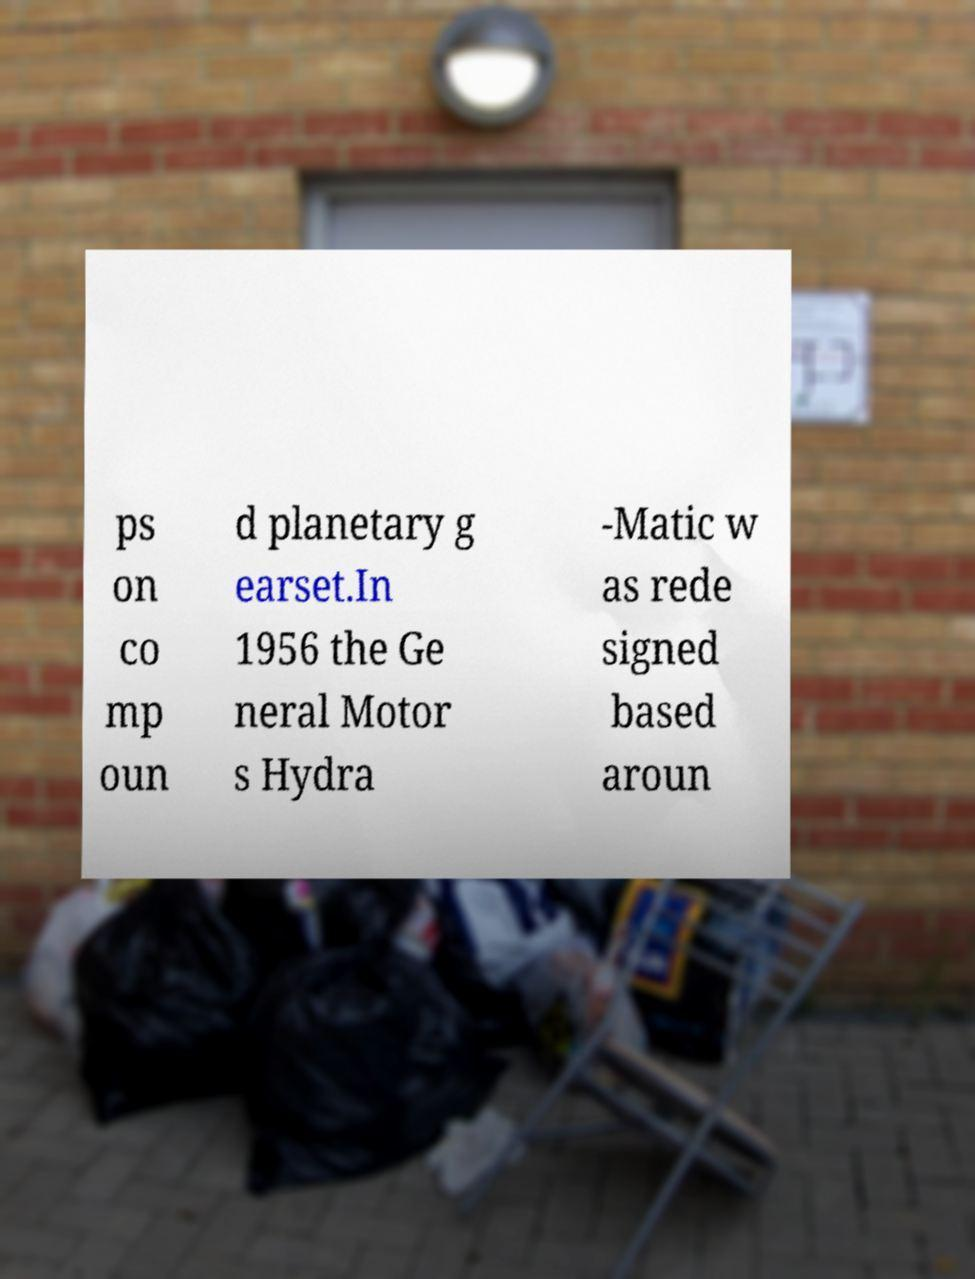Please read and relay the text visible in this image. What does it say? ps on co mp oun d planetary g earset.In 1956 the Ge neral Motor s Hydra -Matic w as rede signed based aroun 